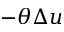Convert formula to latex. <formula><loc_0><loc_0><loc_500><loc_500>- \theta \Delta u</formula> 